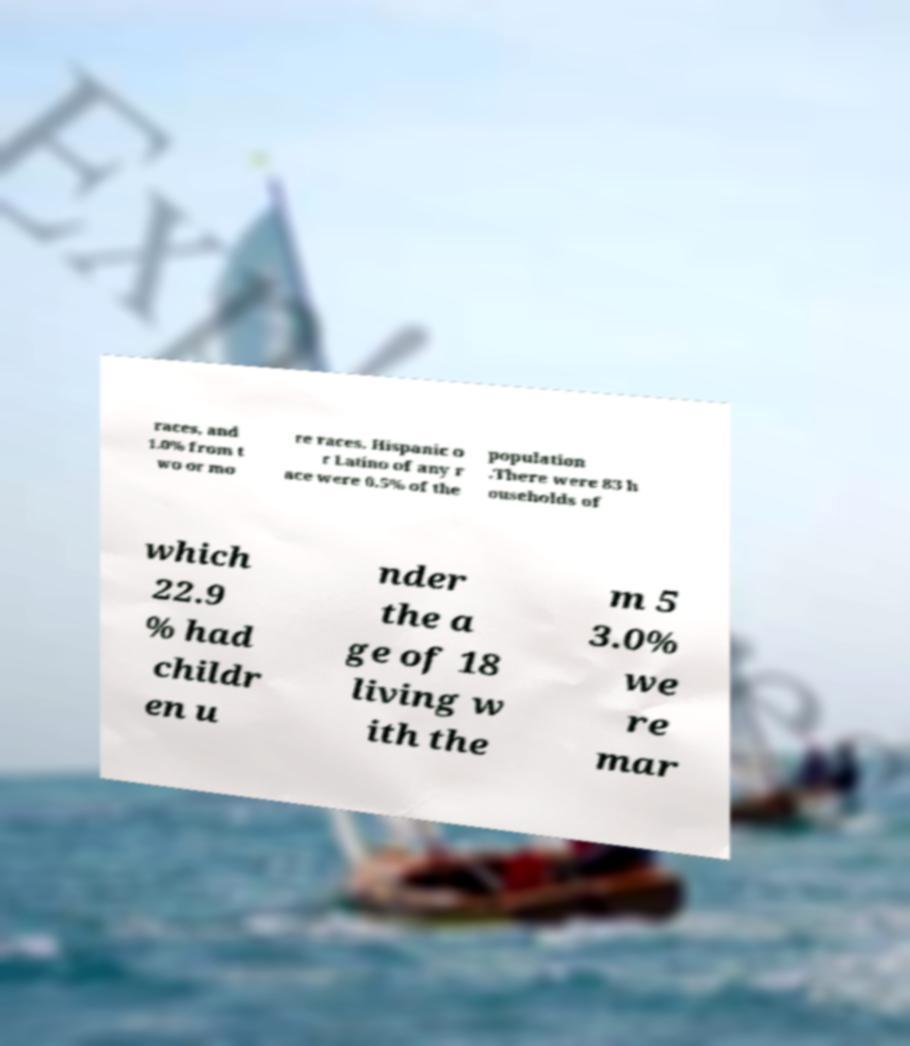Could you assist in decoding the text presented in this image and type it out clearly? races, and 1.0% from t wo or mo re races. Hispanic o r Latino of any r ace were 0.5% of the population .There were 83 h ouseholds of which 22.9 % had childr en u nder the a ge of 18 living w ith the m 5 3.0% we re mar 